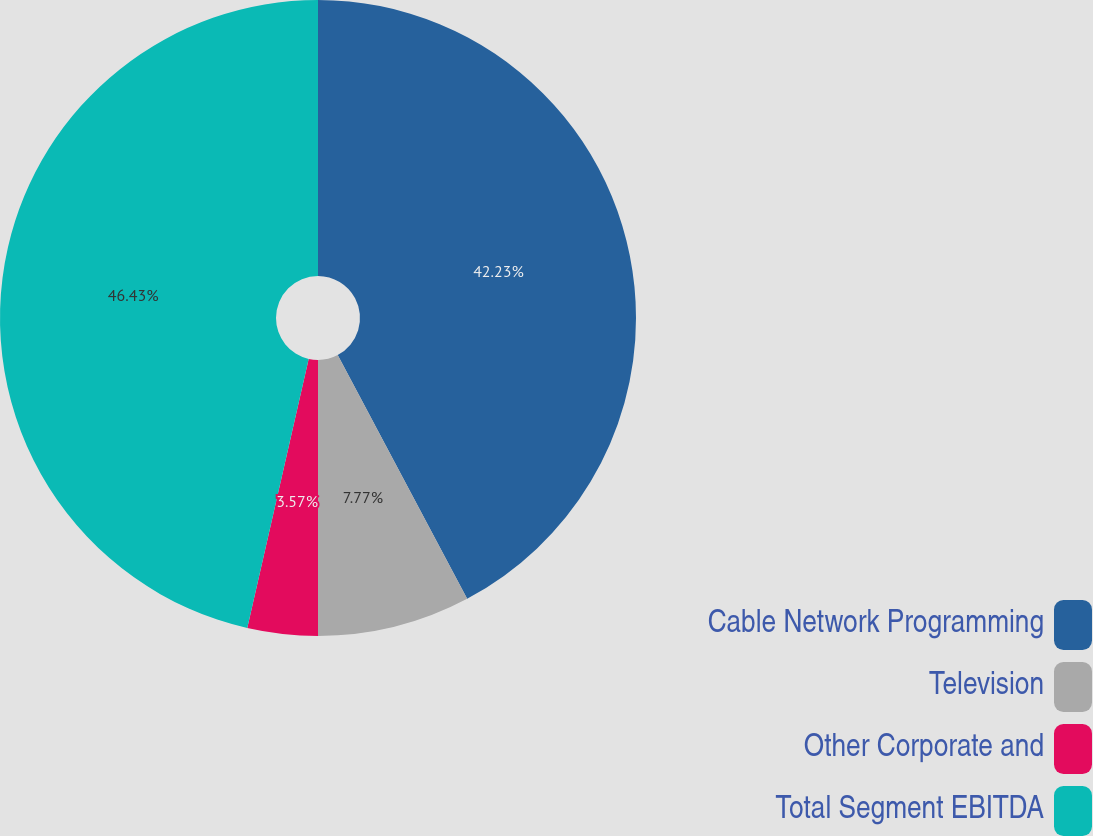<chart> <loc_0><loc_0><loc_500><loc_500><pie_chart><fcel>Cable Network Programming<fcel>Television<fcel>Other Corporate and<fcel>Total Segment EBITDA<nl><fcel>42.23%<fcel>7.77%<fcel>3.57%<fcel>46.43%<nl></chart> 